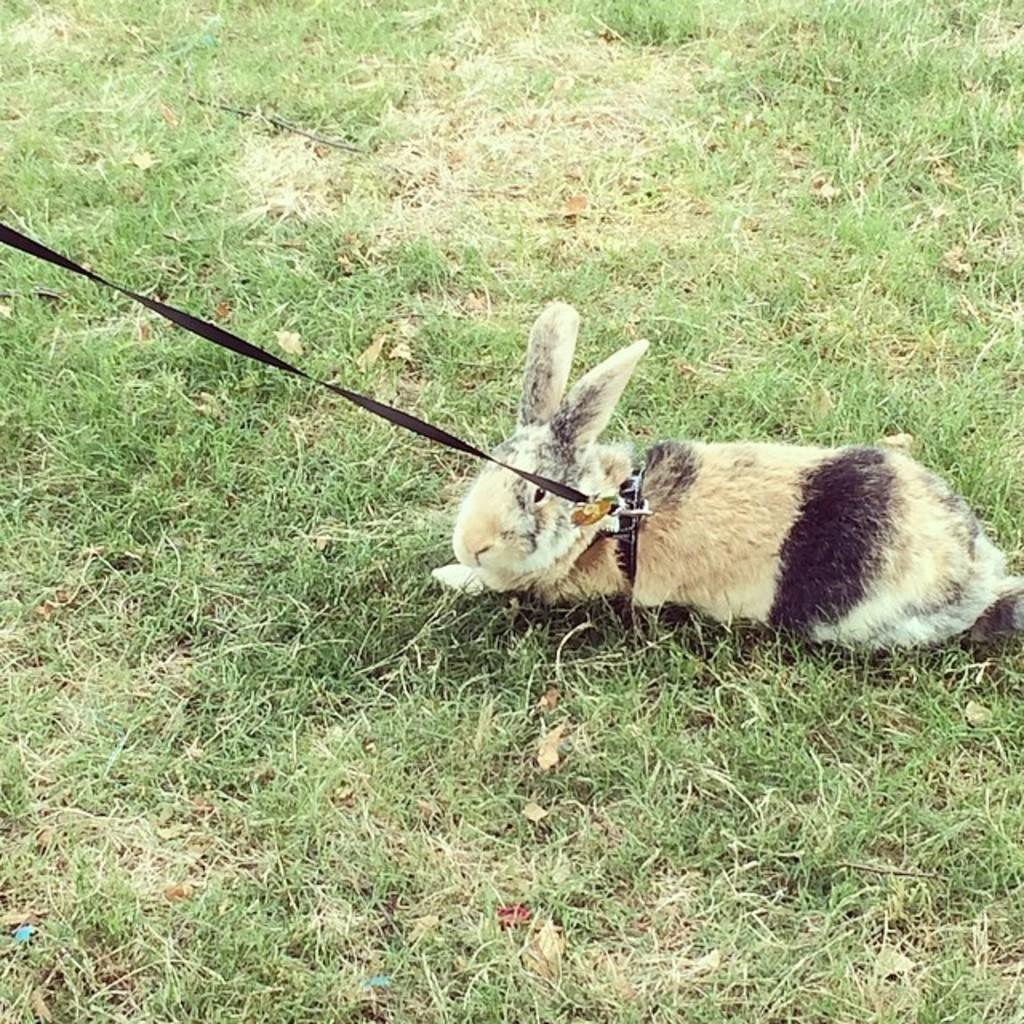What animal is in the middle of the image? There is a rabbit in the middle of the image. Does the rabbit have any accessories? Yes, the rabbit has a collar rope. What is holding the collar rope? The collar rope is held by an object. What type of environment is visible in the background of the image? There is grass visible in the background of the image. What achievements is the rabbit celebrating in the image? There is no indication in the image that the rabbit is celebrating any achievements. How many hands can be seen holding the collar rope in the image? There are no hands visible in the image; the collar rope is held by an object. 